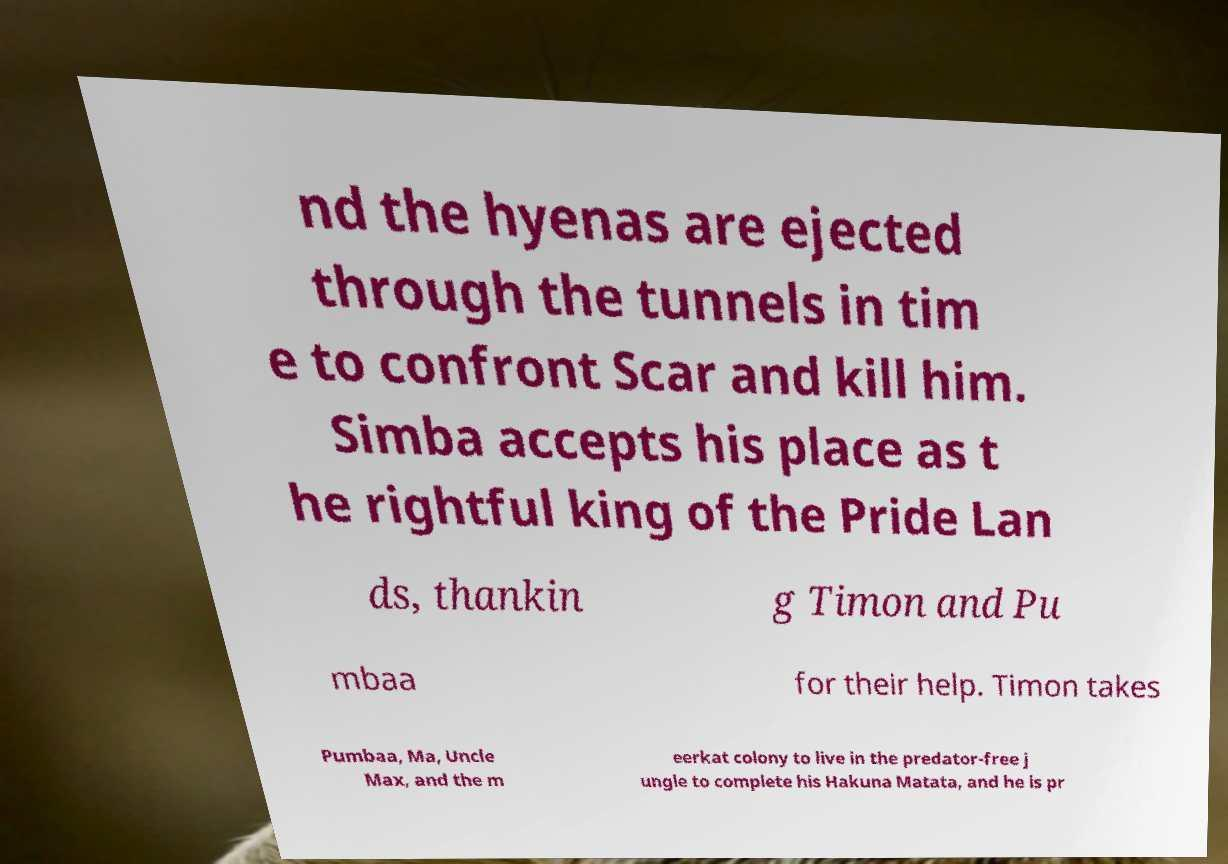Please identify and transcribe the text found in this image. nd the hyenas are ejected through the tunnels in tim e to confront Scar and kill him. Simba accepts his place as t he rightful king of the Pride Lan ds, thankin g Timon and Pu mbaa for their help. Timon takes Pumbaa, Ma, Uncle Max, and the m eerkat colony to live in the predator-free j ungle to complete his Hakuna Matata, and he is pr 